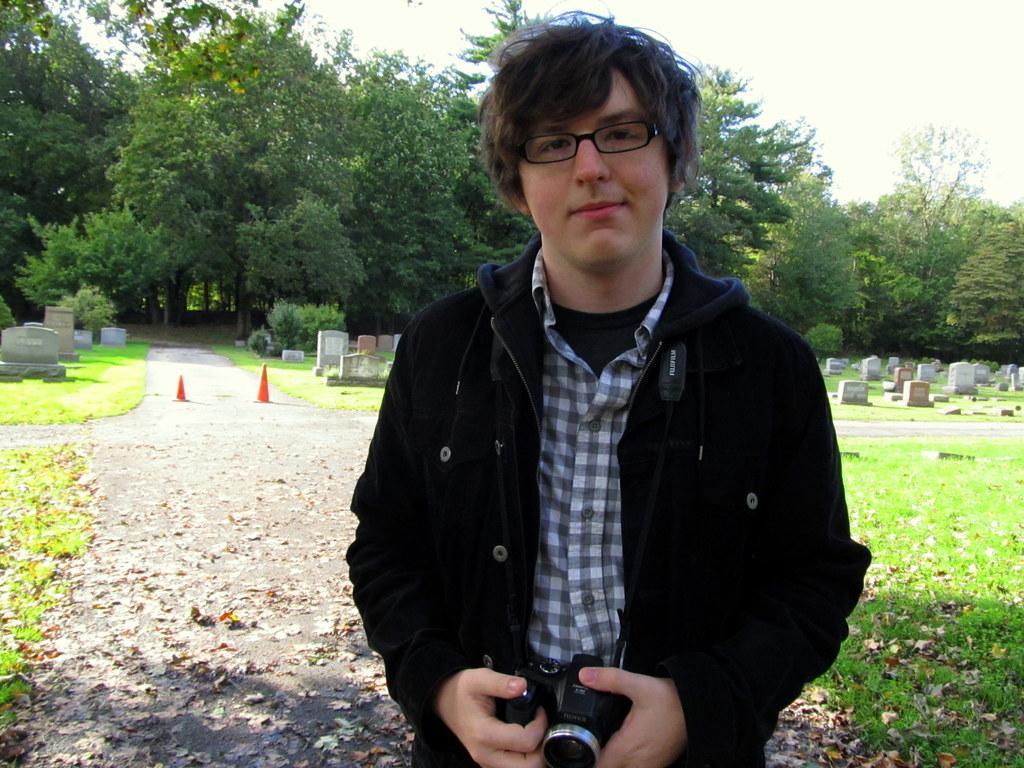How would you summarize this image in a sentence or two? In this image I can see a man is standing in the front, I can see he is wearing shirt, black colour jacket, specs and I can see he is holding up camera. In the background I can see glass, number of tombstones, number of trees and on the left side of this image I can see two orange colour cones on the road. 